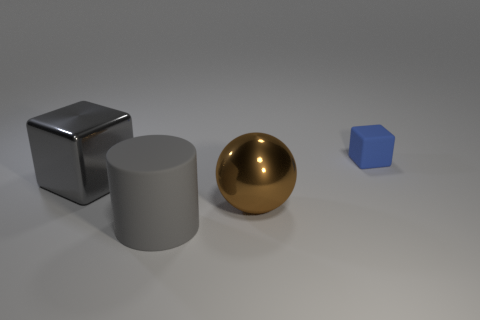Add 4 large gray cubes. How many objects exist? 8 Subtract all spheres. How many objects are left? 3 Add 4 large cubes. How many large cubes are left? 5 Add 2 big gray shiny objects. How many big gray shiny objects exist? 3 Subtract 0 purple spheres. How many objects are left? 4 Subtract all blue spheres. Subtract all purple cylinders. How many spheres are left? 1 Subtract all purple cylinders. How many red balls are left? 0 Subtract all rubber blocks. Subtract all blocks. How many objects are left? 1 